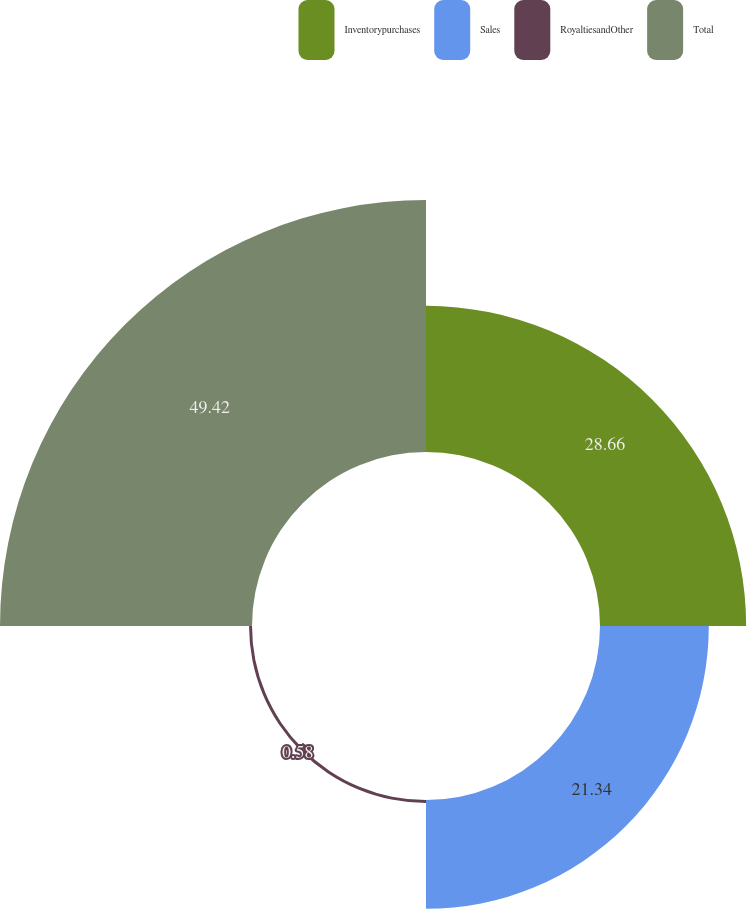<chart> <loc_0><loc_0><loc_500><loc_500><pie_chart><fcel>Inventorypurchases<fcel>Sales<fcel>RoyaltiesandOther<fcel>Total<nl><fcel>28.66%<fcel>21.34%<fcel>0.58%<fcel>49.42%<nl></chart> 